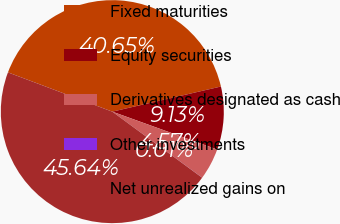Convert chart. <chart><loc_0><loc_0><loc_500><loc_500><pie_chart><fcel>Fixed maturities<fcel>Equity securities<fcel>Derivatives designated as cash<fcel>Other investments<fcel>Net unrealized gains on<nl><fcel>40.65%<fcel>9.13%<fcel>4.57%<fcel>0.01%<fcel>45.64%<nl></chart> 